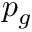Convert formula to latex. <formula><loc_0><loc_0><loc_500><loc_500>p _ { g }</formula> 